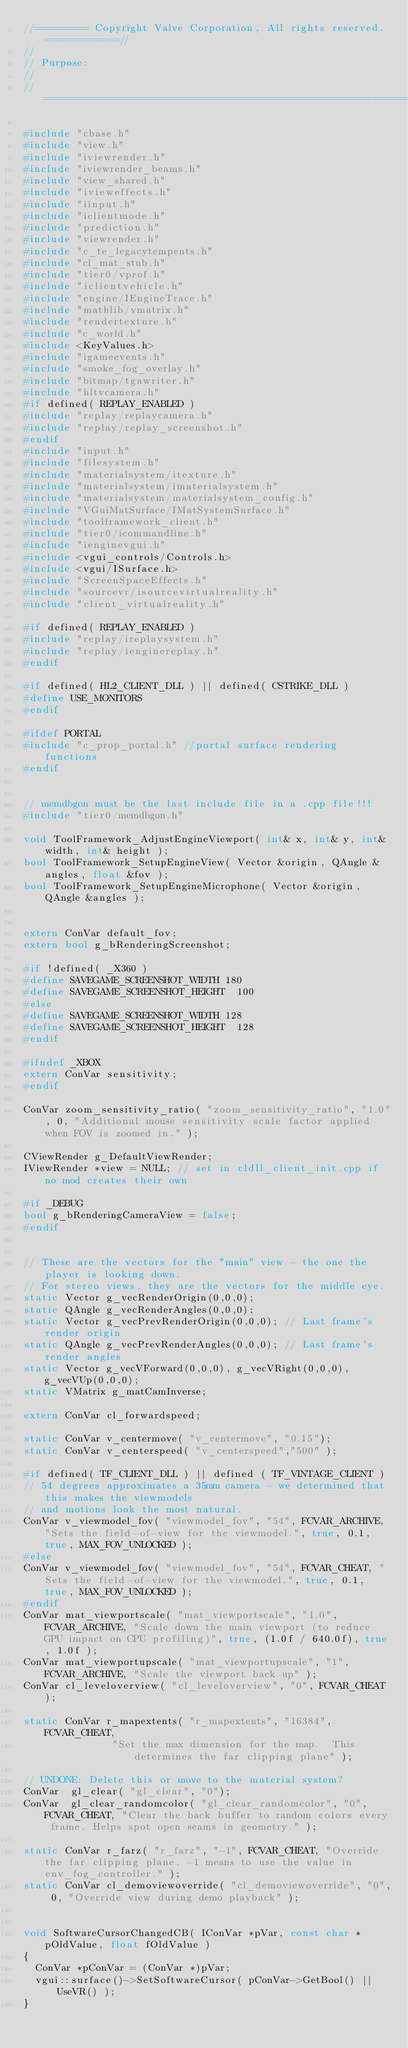<code> <loc_0><loc_0><loc_500><loc_500><_C++_>//========= Copyright Valve Corporation, All rights reserved. ============//
//
// Purpose: 
//
//===========================================================================//

#include "cbase.h"
#include "view.h"
#include "iviewrender.h"
#include "iviewrender_beams.h"
#include "view_shared.h"
#include "ivieweffects.h"
#include "iinput.h"
#include "iclientmode.h"
#include "prediction.h"
#include "viewrender.h"
#include "c_te_legacytempents.h"
#include "cl_mat_stub.h"
#include "tier0/vprof.h"
#include "iclientvehicle.h"
#include "engine/IEngineTrace.h"
#include "mathlib/vmatrix.h"
#include "rendertexture.h"
#include "c_world.h"
#include <KeyValues.h>
#include "igameevents.h"
#include "smoke_fog_overlay.h"
#include "bitmap/tgawriter.h"
#include "hltvcamera.h"
#if defined( REPLAY_ENABLED )
#include "replay/replaycamera.h"
#include "replay/replay_screenshot.h"
#endif
#include "input.h"
#include "filesystem.h"
#include "materialsystem/itexture.h"
#include "materialsystem/imaterialsystem.h"
#include "materialsystem/materialsystem_config.h"
#include "VGuiMatSurface/IMatSystemSurface.h"
#include "toolframework_client.h"
#include "tier0/icommandline.h"
#include "ienginevgui.h"
#include <vgui_controls/Controls.h>
#include <vgui/ISurface.h>
#include "ScreenSpaceEffects.h"
#include "sourcevr/isourcevirtualreality.h"
#include "client_virtualreality.h"

#if defined( REPLAY_ENABLED )
#include "replay/ireplaysystem.h"
#include "replay/ienginereplay.h"
#endif

#if defined( HL2_CLIENT_DLL ) || defined( CSTRIKE_DLL )
#define USE_MONITORS
#endif

#ifdef PORTAL
#include "c_prop_portal.h" //portal surface rendering functions
#endif

	
// memdbgon must be the last include file in a .cpp file!!!
#include "tier0/memdbgon.h"
		  
void ToolFramework_AdjustEngineViewport( int& x, int& y, int& width, int& height );
bool ToolFramework_SetupEngineView( Vector &origin, QAngle &angles, float &fov );
bool ToolFramework_SetupEngineMicrophone( Vector &origin, QAngle &angles );


extern ConVar default_fov;
extern bool g_bRenderingScreenshot;

#if !defined( _X360 )
#define SAVEGAME_SCREENSHOT_WIDTH	180
#define SAVEGAME_SCREENSHOT_HEIGHT	100
#else
#define SAVEGAME_SCREENSHOT_WIDTH	128
#define SAVEGAME_SCREENSHOT_HEIGHT	128
#endif

#ifndef _XBOX
extern ConVar sensitivity;
#endif

ConVar zoom_sensitivity_ratio( "zoom_sensitivity_ratio", "1.0", 0, "Additional mouse sensitivity scale factor applied when FOV is zoomed in." );

CViewRender g_DefaultViewRender;
IViewRender *view = NULL;	// set in cldll_client_init.cpp if no mod creates their own

#if _DEBUG
bool g_bRenderingCameraView = false;
#endif


// These are the vectors for the "main" view - the one the player is looking down.
// For stereo views, they are the vectors for the middle eye.
static Vector g_vecRenderOrigin(0,0,0);
static QAngle g_vecRenderAngles(0,0,0);
static Vector g_vecPrevRenderOrigin(0,0,0);	// Last frame's render origin
static QAngle g_vecPrevRenderAngles(0,0,0); // Last frame's render angles
static Vector g_vecVForward(0,0,0), g_vecVRight(0,0,0), g_vecVUp(0,0,0);
static VMatrix g_matCamInverse;

extern ConVar cl_forwardspeed;

static ConVar v_centermove( "v_centermove", "0.15");
static ConVar v_centerspeed( "v_centerspeed","500" );

#if defined( TF_CLIENT_DLL ) || defined ( TF_VINTAGE_CLIENT )
// 54 degrees approximates a 35mm camera - we determined that this makes the viewmodels
// and motions look the most natural.
ConVar v_viewmodel_fov( "viewmodel_fov", "54", FCVAR_ARCHIVE, "Sets the field-of-view for the viewmodel.", true, 0.1, true, MAX_FOV_UNLOCKED );
#else
ConVar v_viewmodel_fov( "viewmodel_fov", "54", FCVAR_CHEAT, "Sets the field-of-view for the viewmodel.", true, 0.1, true, MAX_FOV_UNLOCKED );
#endif
ConVar mat_viewportscale( "mat_viewportscale", "1.0", FCVAR_ARCHIVE, "Scale down the main viewport (to reduce GPU impact on CPU profiling)", true, (1.0f / 640.0f), true, 1.0f );
ConVar mat_viewportupscale( "mat_viewportupscale", "1", FCVAR_ARCHIVE, "Scale the viewport back up" );
ConVar cl_leveloverview( "cl_leveloverview", "0", FCVAR_CHEAT );

static ConVar r_mapextents( "r_mapextents", "16384", FCVAR_CHEAT, 
						   "Set the max dimension for the map.  This determines the far clipping plane" );

// UNDONE: Delete this or move to the material system?
ConVar	gl_clear( "gl_clear", "0");
ConVar	gl_clear_randomcolor( "gl_clear_randomcolor", "0", FCVAR_CHEAT, "Clear the back buffer to random colors every frame. Helps spot open seams in geometry." );

static ConVar r_farz( "r_farz", "-1", FCVAR_CHEAT, "Override the far clipping plane. -1 means to use the value in env_fog_controller." );
static ConVar cl_demoviewoverride( "cl_demoviewoverride", "0", 0, "Override view during demo playback" );


void SoftwareCursorChangedCB( IConVar *pVar, const char *pOldValue, float fOldValue )
{
	ConVar *pConVar = (ConVar *)pVar;
	vgui::surface()->SetSoftwareCursor( pConVar->GetBool() || UseVR() );
}</code> 